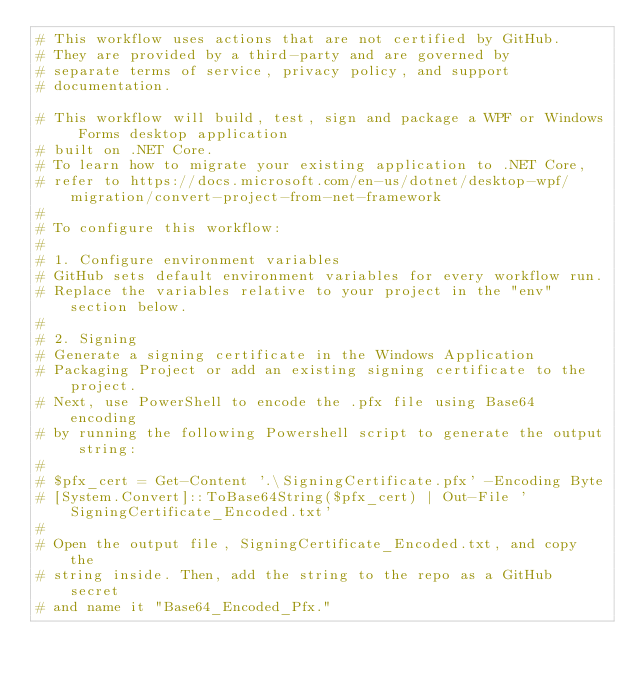<code> <loc_0><loc_0><loc_500><loc_500><_YAML_># This workflow uses actions that are not certified by GitHub.
# They are provided by a third-party and are governed by
# separate terms of service, privacy policy, and support
# documentation.

# This workflow will build, test, sign and package a WPF or Windows Forms desktop application
# built on .NET Core.
# To learn how to migrate your existing application to .NET Core,
# refer to https://docs.microsoft.com/en-us/dotnet/desktop-wpf/migration/convert-project-from-net-framework
#
# To configure this workflow:
#
# 1. Configure environment variables
# GitHub sets default environment variables for every workflow run.
# Replace the variables relative to your project in the "env" section below.
#
# 2. Signing
# Generate a signing certificate in the Windows Application
# Packaging Project or add an existing signing certificate to the project.
# Next, use PowerShell to encode the .pfx file using Base64 encoding
# by running the following Powershell script to generate the output string:
#
# $pfx_cert = Get-Content '.\SigningCertificate.pfx' -Encoding Byte
# [System.Convert]::ToBase64String($pfx_cert) | Out-File 'SigningCertificate_Encoded.txt'
#
# Open the output file, SigningCertificate_Encoded.txt, and copy the
# string inside. Then, add the string to the repo as a GitHub secret
# and name it "Base64_Encoded_Pfx."</code> 